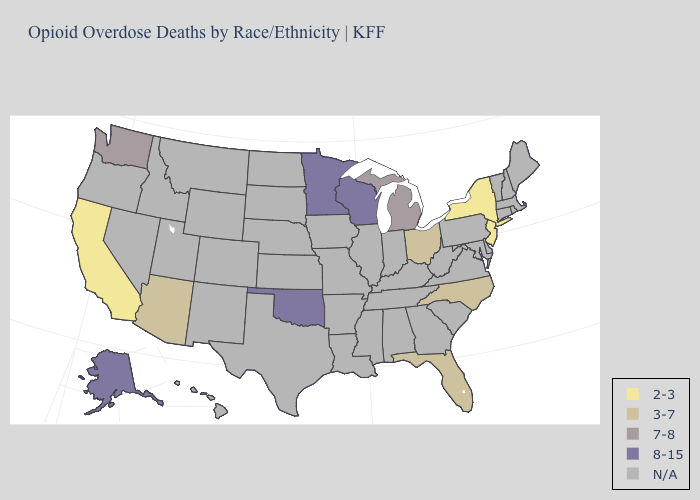Name the states that have a value in the range 2-3?
Give a very brief answer. California, New Jersey, New York. What is the lowest value in the South?
Concise answer only. 3-7. How many symbols are there in the legend?
Answer briefly. 5. What is the value of Alabama?
Short answer required. N/A. Name the states that have a value in the range 7-8?
Give a very brief answer. Michigan, Washington. Which states have the lowest value in the West?
Short answer required. California. What is the value of Alaska?
Give a very brief answer. 8-15. Does Wisconsin have the lowest value in the MidWest?
Answer briefly. No. Among the states that border California , which have the highest value?
Be succinct. Arizona. Name the states that have a value in the range 8-15?
Give a very brief answer. Alaska, Minnesota, Oklahoma, Wisconsin. Does the map have missing data?
Short answer required. Yes. Name the states that have a value in the range N/A?
Concise answer only. Alabama, Arkansas, Colorado, Connecticut, Delaware, Georgia, Hawaii, Idaho, Illinois, Indiana, Iowa, Kansas, Kentucky, Louisiana, Maine, Maryland, Massachusetts, Mississippi, Missouri, Montana, Nebraska, Nevada, New Hampshire, New Mexico, North Dakota, Oregon, Pennsylvania, Rhode Island, South Carolina, South Dakota, Tennessee, Texas, Utah, Vermont, Virginia, West Virginia, Wyoming. 